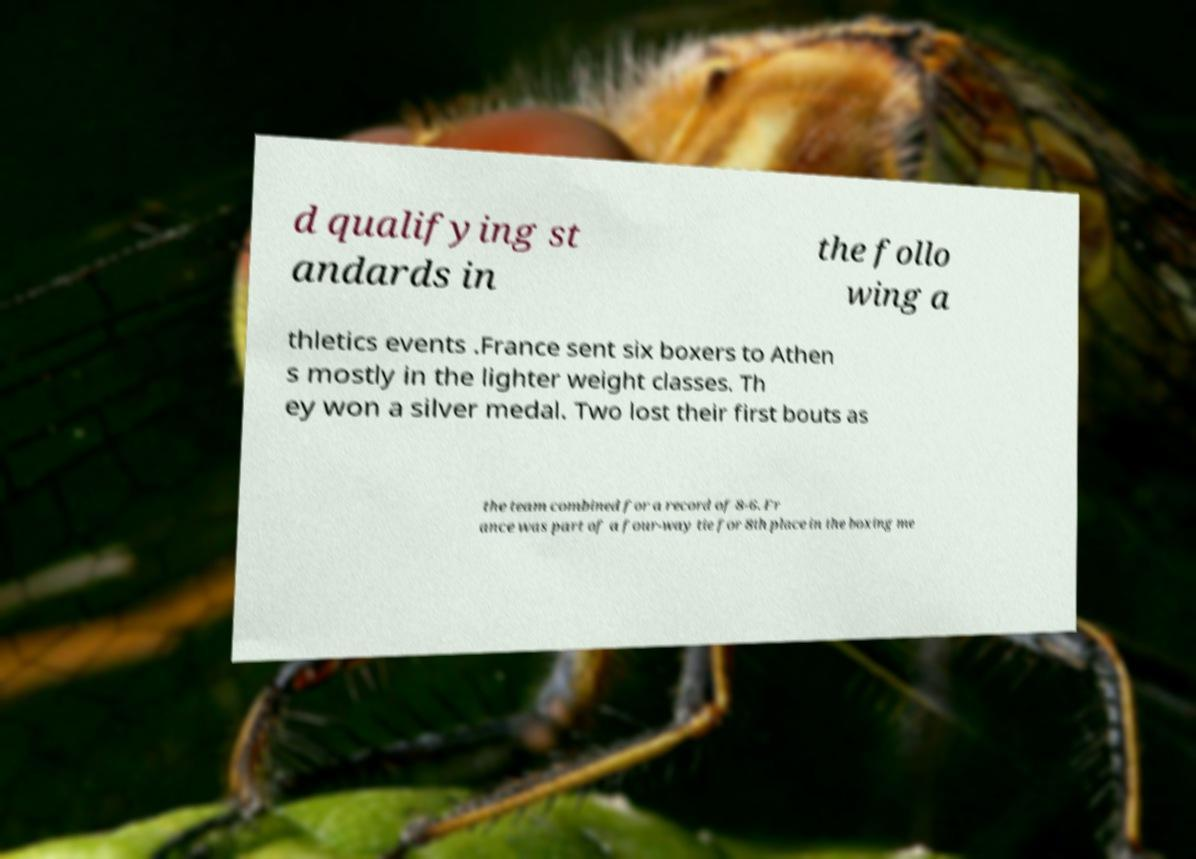What messages or text are displayed in this image? I need them in a readable, typed format. d qualifying st andards in the follo wing a thletics events .France sent six boxers to Athen s mostly in the lighter weight classes. Th ey won a silver medal. Two lost their first bouts as the team combined for a record of 8-6. Fr ance was part of a four-way tie for 8th place in the boxing me 